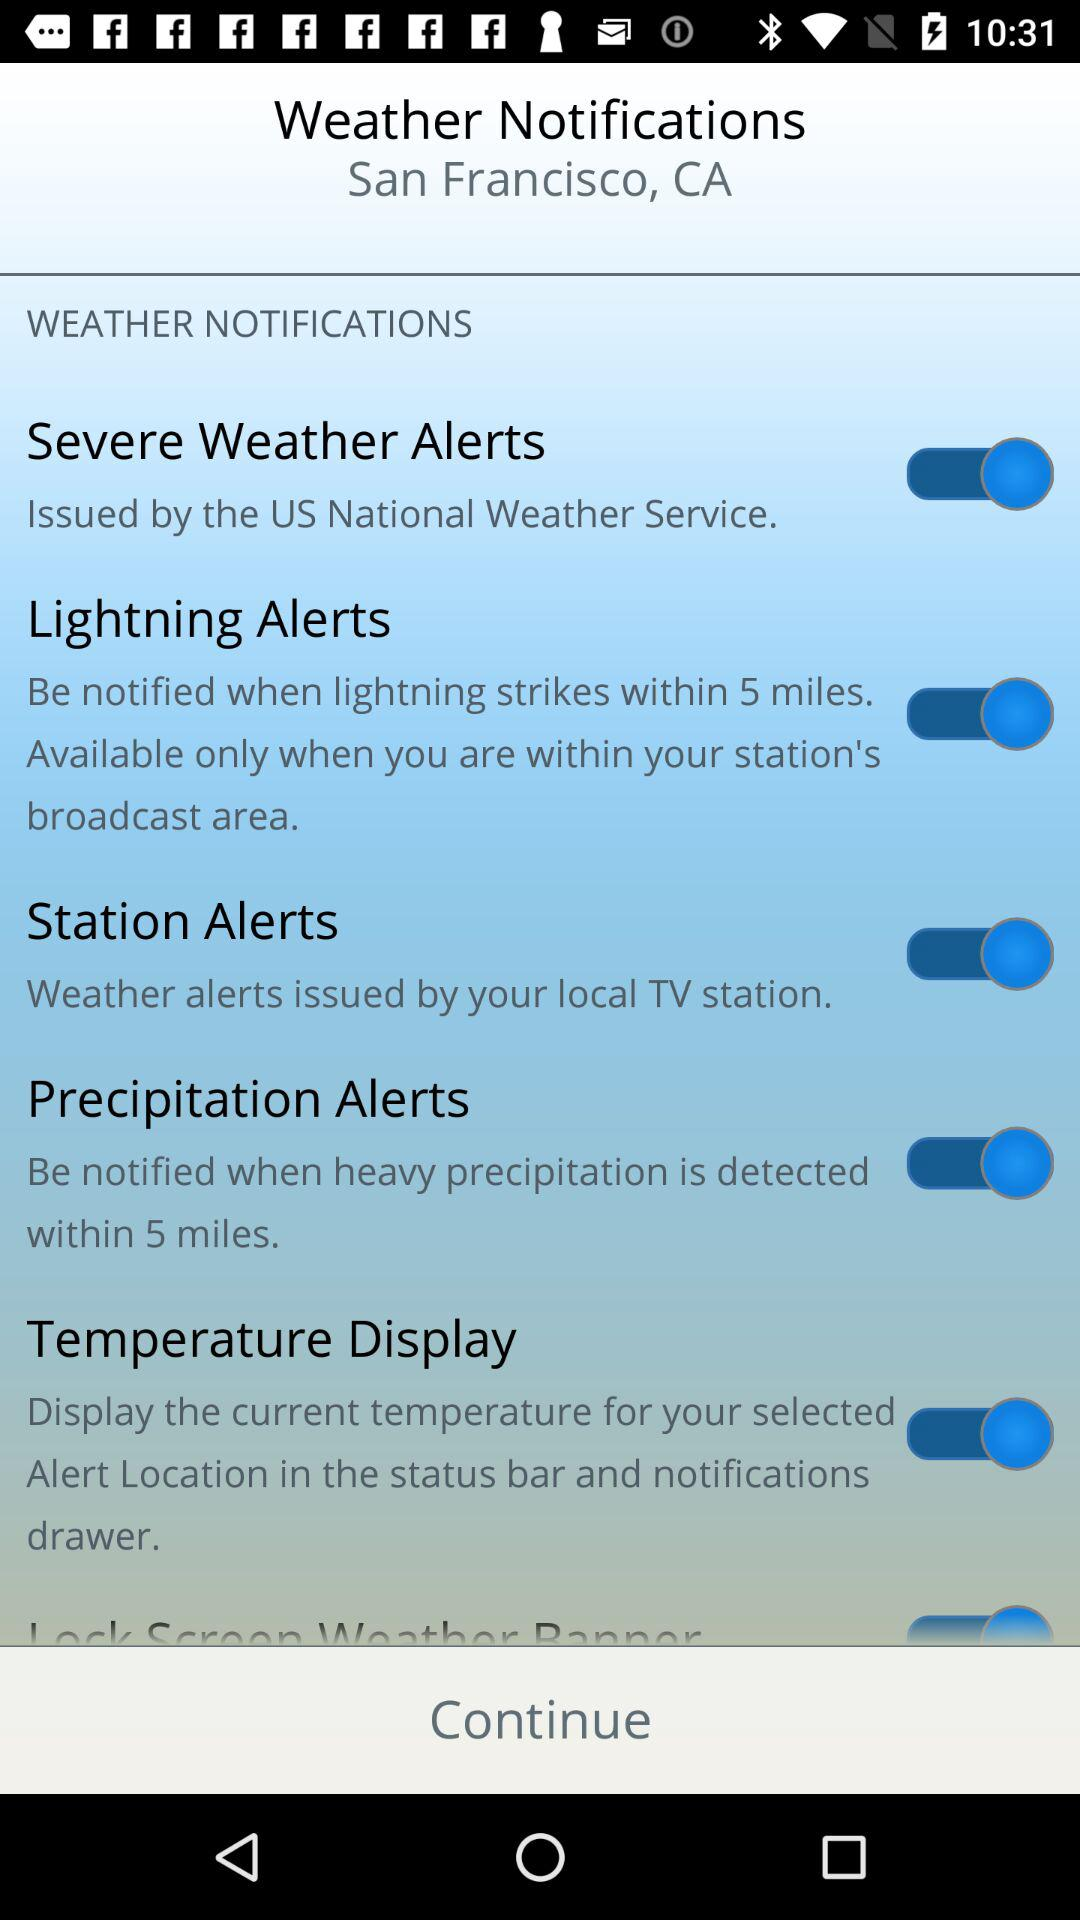When precipitation is detected, within how many miles will I be notified? You will be notified within 5 miles. 